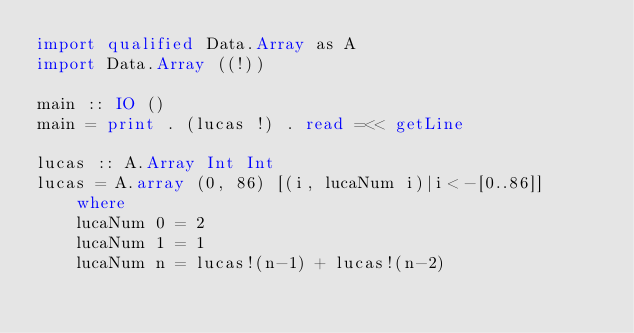<code> <loc_0><loc_0><loc_500><loc_500><_Haskell_>import qualified Data.Array as A
import Data.Array ((!))

main :: IO ()
main = print . (lucas !) . read =<< getLine
    
lucas :: A.Array Int Int
lucas = A.array (0, 86) [(i, lucaNum i)|i<-[0..86]]
    where 
    lucaNum 0 = 2
    lucaNum 1 = 1
    lucaNum n = lucas!(n-1) + lucas!(n-2)</code> 